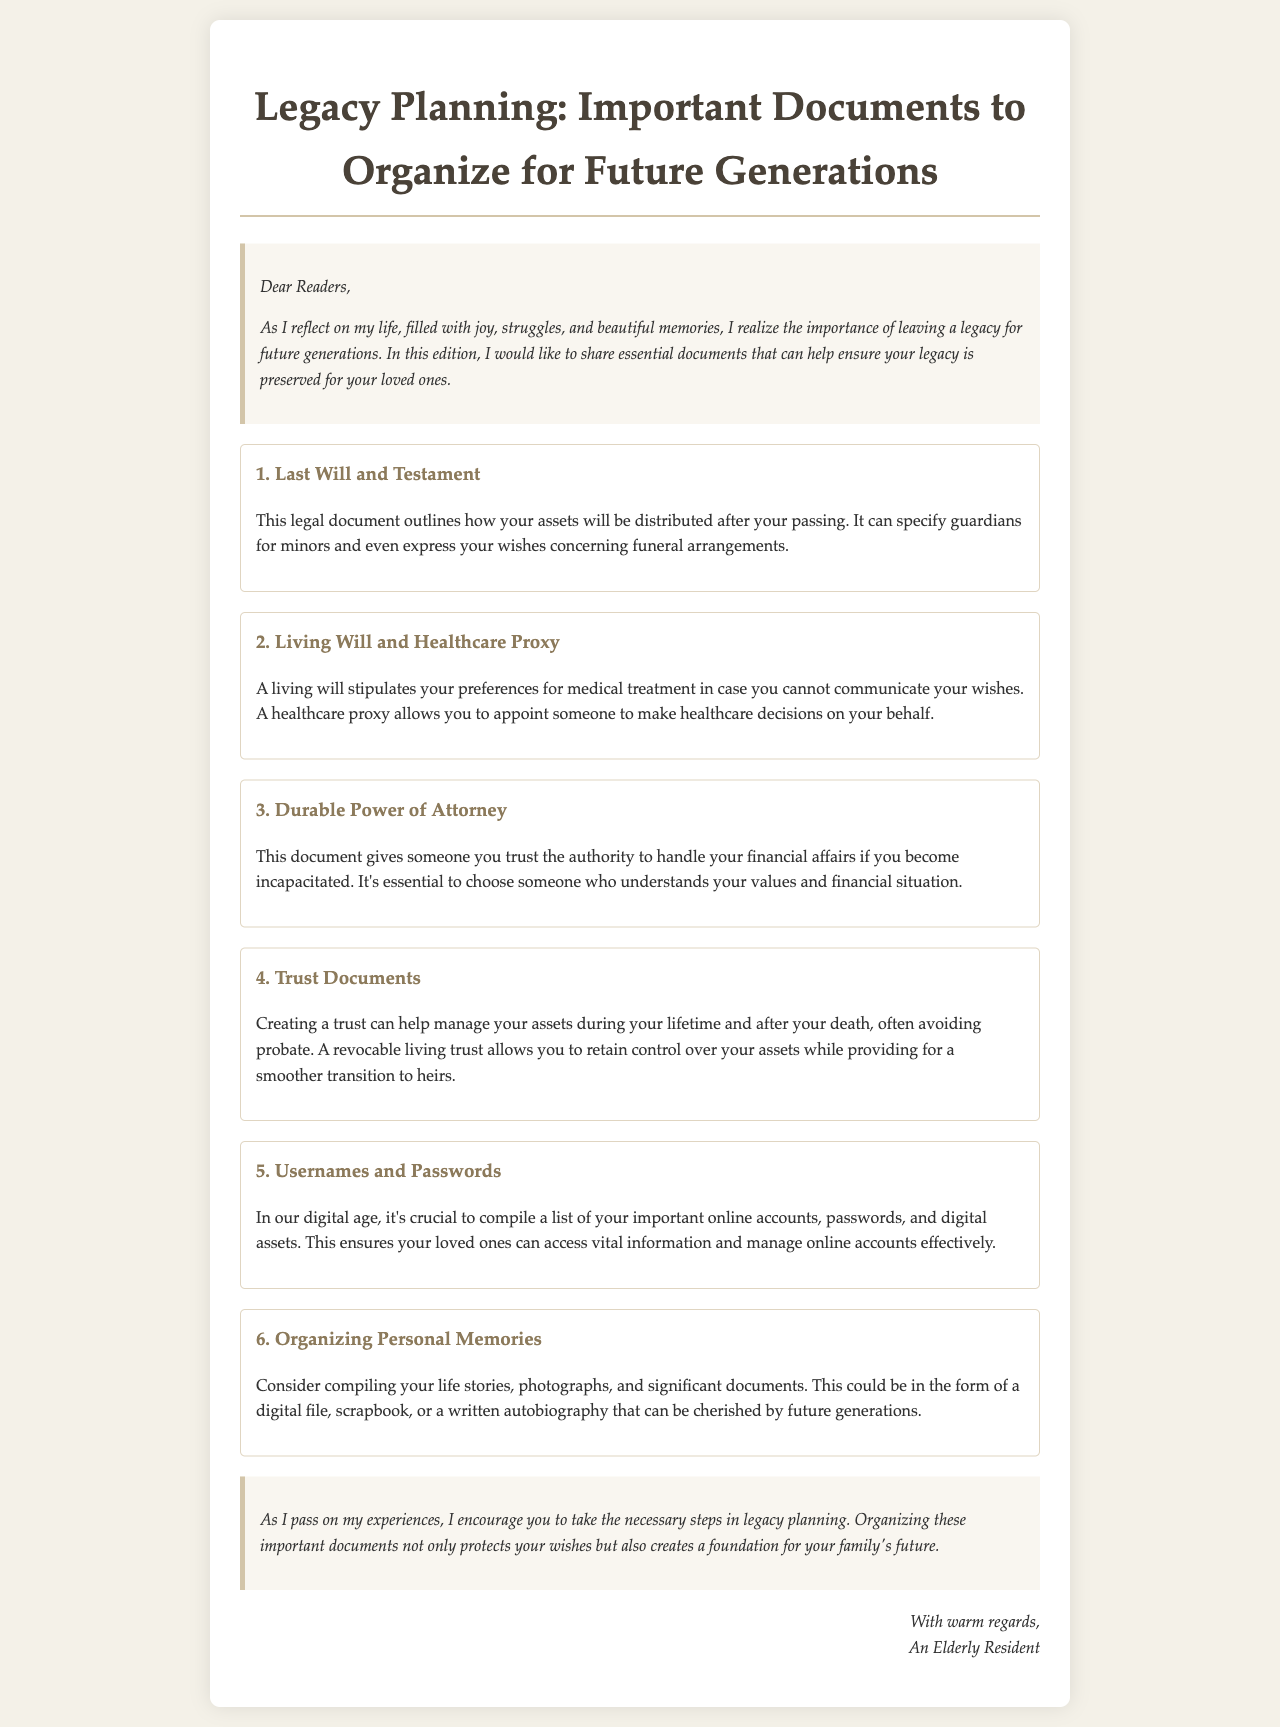What is the title of the newsletter? The title is stated in the heading of the document.
Answer: Legacy Planning: Important Documents to Organize for Future Generations What is the first document mentioned? The first document is listed in the content section of the newsletter.
Answer: Last Will and Testament What does a living will specify? This information is provided in the description of the second document.
Answer: Preferences for medical treatment How many essential documents are listed in total? The number of documents is derived from the list in the content section.
Answer: Six What is a durable power of attorney? The newsletter defines this document in the third content item.
Answer: Authority to handle financial affairs What is an example of organizing personal memories? This is mentioned in the description of the sixth document.
Answer: Scrapbook What is one benefit of creating a trust? The benefit is elaborated in the overview of trust documents.
Answer: Avoiding probate Who is the author of the newsletter? The author is identified in the closing signature of the document.
Answer: An Elderly Resident 